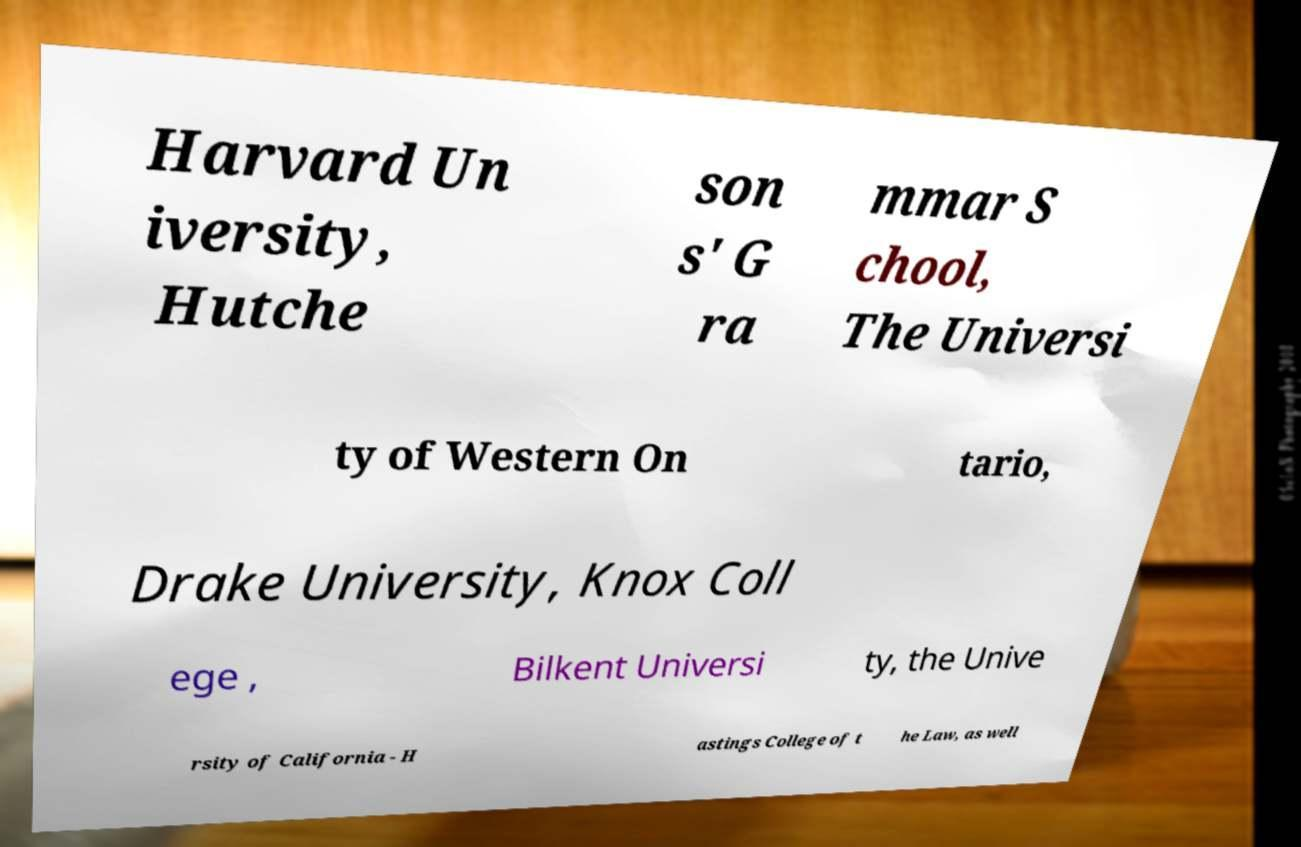Could you assist in decoding the text presented in this image and type it out clearly? Harvard Un iversity, Hutche son s' G ra mmar S chool, The Universi ty of Western On tario, Drake University, Knox Coll ege , Bilkent Universi ty, the Unive rsity of California - H astings College of t he Law, as well 